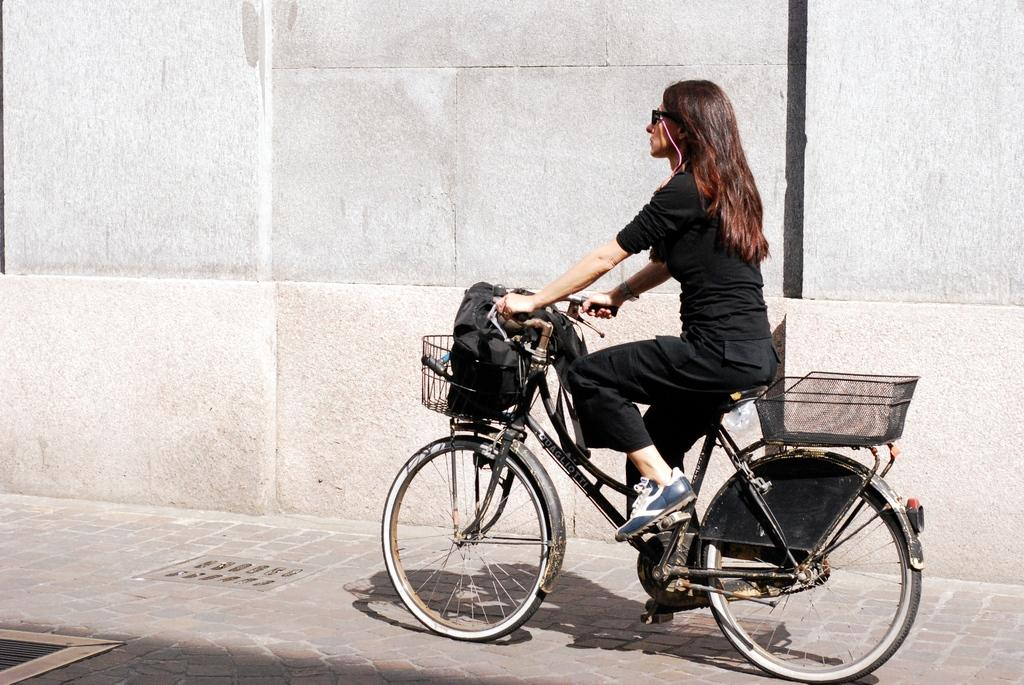Who is the main subject in the image? There is a woman in the image. What is the woman doing in the image? The woman is riding a bicycle. What features does the bicycle have? The bicycle has baskets in the front and back. What can be seen in the background of the image? There is a wall in the background of the image. How many children are playing with the woman's nerves in the image? There are no children or nerves present in the image; it features a woman riding a bicycle with baskets. 